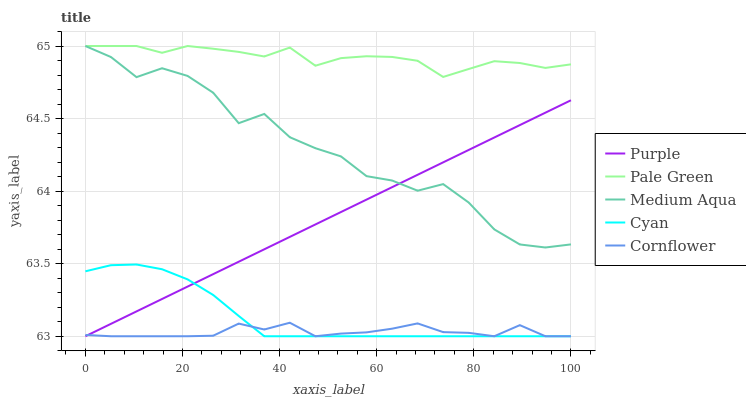Does Cornflower have the minimum area under the curve?
Answer yes or no. Yes. Does Pale Green have the maximum area under the curve?
Answer yes or no. Yes. Does Cyan have the minimum area under the curve?
Answer yes or no. No. Does Cyan have the maximum area under the curve?
Answer yes or no. No. Is Purple the smoothest?
Answer yes or no. Yes. Is Medium Aqua the roughest?
Answer yes or no. Yes. Is Cyan the smoothest?
Answer yes or no. No. Is Cyan the roughest?
Answer yes or no. No. Does Pale Green have the lowest value?
Answer yes or no. No. Does Cyan have the highest value?
Answer yes or no. No. Is Cyan less than Medium Aqua?
Answer yes or no. Yes. Is Pale Green greater than Cyan?
Answer yes or no. Yes. Does Cyan intersect Medium Aqua?
Answer yes or no. No. 